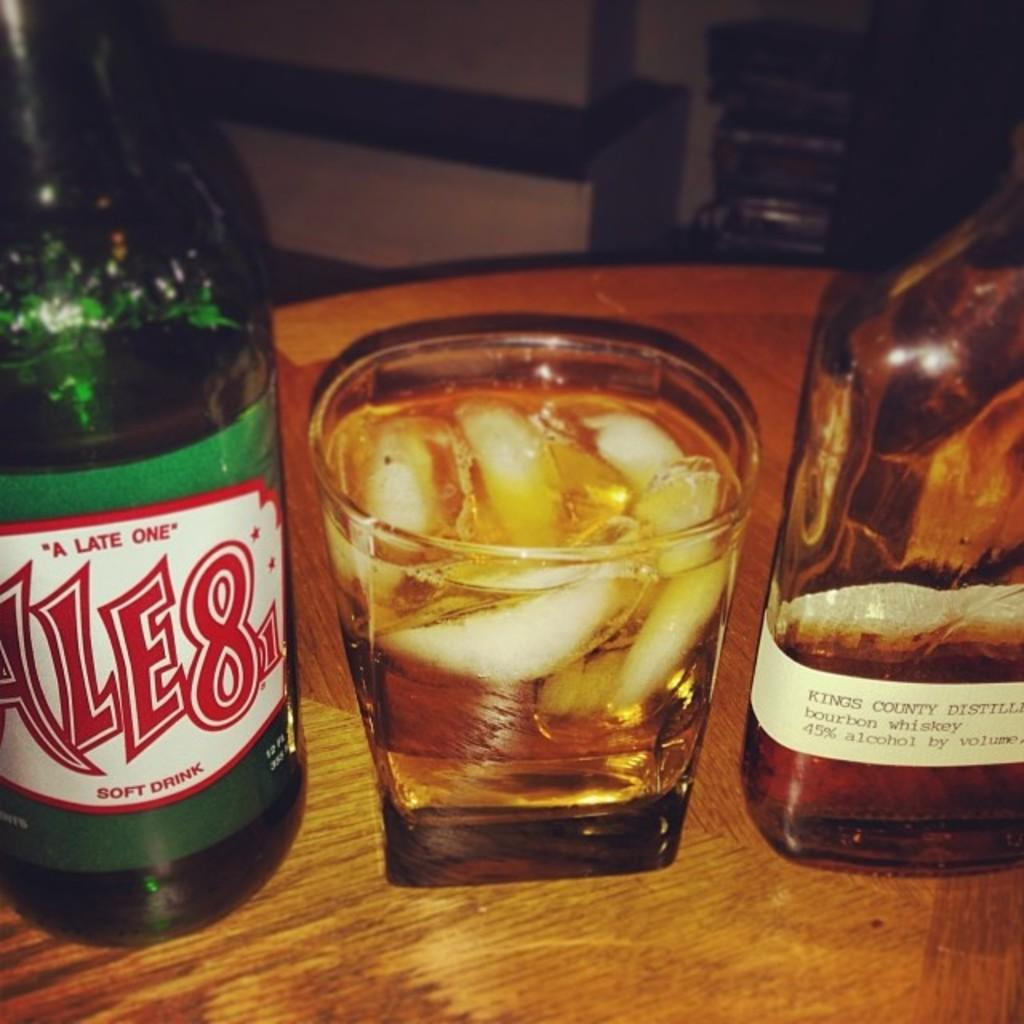What piece of furniture is present in the image? There is a table in the image. What objects are on the table? There are two bottles and one glass on the table. Who is the manager of the geese in the image? There are no geese or managers present in the image. 